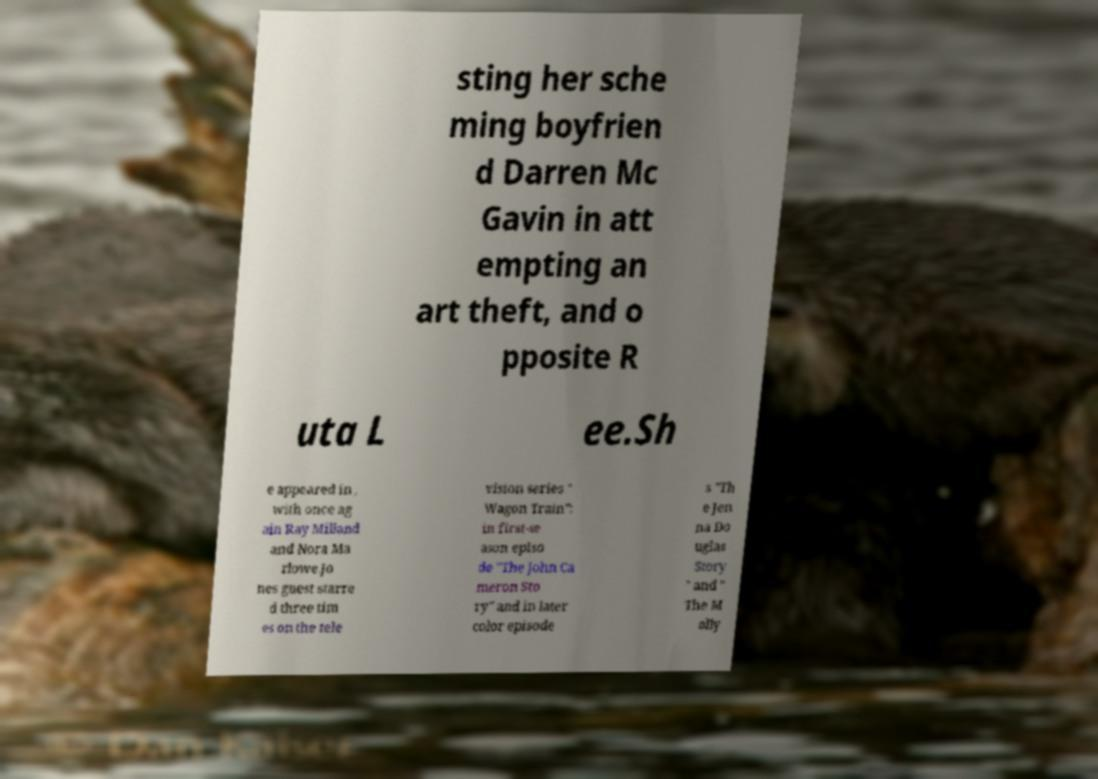Please read and relay the text visible in this image. What does it say? sting her sche ming boyfrien d Darren Mc Gavin in att empting an art theft, and o pposite R uta L ee.Sh e appeared in , with once ag ain Ray Milland and Nora Ma rlowe.Jo nes guest starre d three tim es on the tele vision series " Wagon Train": in first-se ason episo de "The John Ca meron Sto ry" and in later color episode s "Th e Jen na Do uglas Story " and " The M olly 